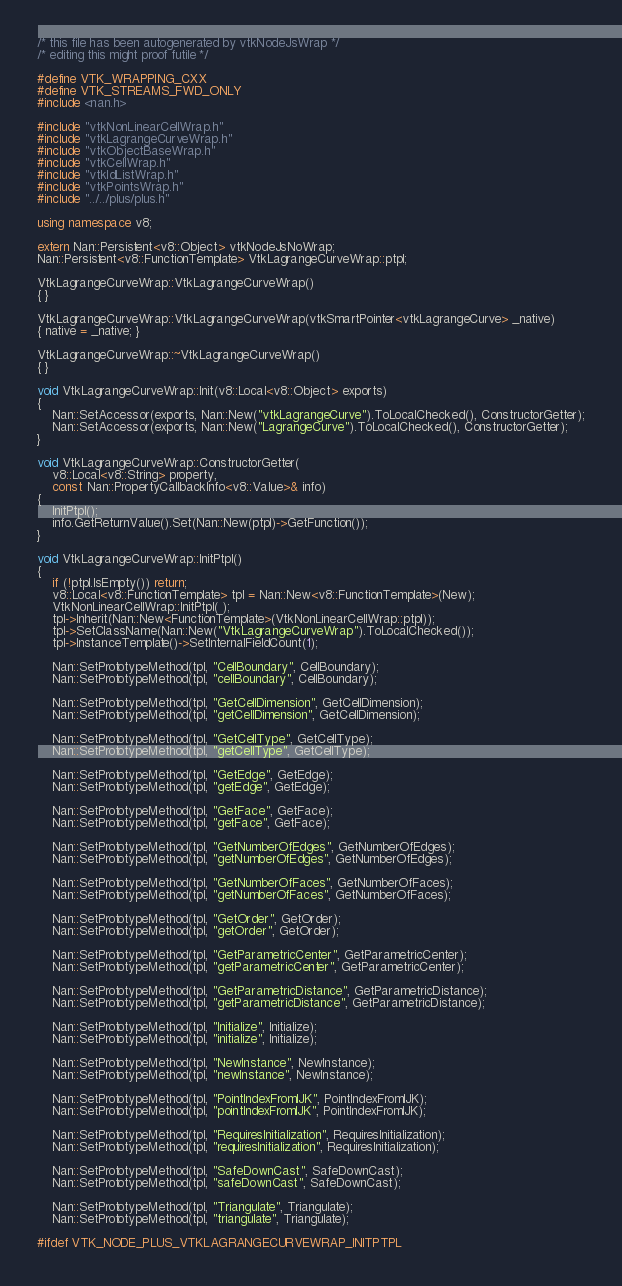Convert code to text. <code><loc_0><loc_0><loc_500><loc_500><_C++_>/* this file has been autogenerated by vtkNodeJsWrap */
/* editing this might proof futile */

#define VTK_WRAPPING_CXX
#define VTK_STREAMS_FWD_ONLY
#include <nan.h>

#include "vtkNonLinearCellWrap.h"
#include "vtkLagrangeCurveWrap.h"
#include "vtkObjectBaseWrap.h"
#include "vtkCellWrap.h"
#include "vtkIdListWrap.h"
#include "vtkPointsWrap.h"
#include "../../plus/plus.h"

using namespace v8;

extern Nan::Persistent<v8::Object> vtkNodeJsNoWrap;
Nan::Persistent<v8::FunctionTemplate> VtkLagrangeCurveWrap::ptpl;

VtkLagrangeCurveWrap::VtkLagrangeCurveWrap()
{ }

VtkLagrangeCurveWrap::VtkLagrangeCurveWrap(vtkSmartPointer<vtkLagrangeCurve> _native)
{ native = _native; }

VtkLagrangeCurveWrap::~VtkLagrangeCurveWrap()
{ }

void VtkLagrangeCurveWrap::Init(v8::Local<v8::Object> exports)
{
	Nan::SetAccessor(exports, Nan::New("vtkLagrangeCurve").ToLocalChecked(), ConstructorGetter);
	Nan::SetAccessor(exports, Nan::New("LagrangeCurve").ToLocalChecked(), ConstructorGetter);
}

void VtkLagrangeCurveWrap::ConstructorGetter(
	v8::Local<v8::String> property,
	const Nan::PropertyCallbackInfo<v8::Value>& info)
{
	InitPtpl();
	info.GetReturnValue().Set(Nan::New(ptpl)->GetFunction());
}

void VtkLagrangeCurveWrap::InitPtpl()
{
	if (!ptpl.IsEmpty()) return;
	v8::Local<v8::FunctionTemplate> tpl = Nan::New<v8::FunctionTemplate>(New);
	VtkNonLinearCellWrap::InitPtpl( );
	tpl->Inherit(Nan::New<FunctionTemplate>(VtkNonLinearCellWrap::ptpl));
	tpl->SetClassName(Nan::New("VtkLagrangeCurveWrap").ToLocalChecked());
	tpl->InstanceTemplate()->SetInternalFieldCount(1);

	Nan::SetPrototypeMethod(tpl, "CellBoundary", CellBoundary);
	Nan::SetPrototypeMethod(tpl, "cellBoundary", CellBoundary);

	Nan::SetPrototypeMethod(tpl, "GetCellDimension", GetCellDimension);
	Nan::SetPrototypeMethod(tpl, "getCellDimension", GetCellDimension);

	Nan::SetPrototypeMethod(tpl, "GetCellType", GetCellType);
	Nan::SetPrototypeMethod(tpl, "getCellType", GetCellType);

	Nan::SetPrototypeMethod(tpl, "GetEdge", GetEdge);
	Nan::SetPrototypeMethod(tpl, "getEdge", GetEdge);

	Nan::SetPrototypeMethod(tpl, "GetFace", GetFace);
	Nan::SetPrototypeMethod(tpl, "getFace", GetFace);

	Nan::SetPrototypeMethod(tpl, "GetNumberOfEdges", GetNumberOfEdges);
	Nan::SetPrototypeMethod(tpl, "getNumberOfEdges", GetNumberOfEdges);

	Nan::SetPrototypeMethod(tpl, "GetNumberOfFaces", GetNumberOfFaces);
	Nan::SetPrototypeMethod(tpl, "getNumberOfFaces", GetNumberOfFaces);

	Nan::SetPrototypeMethod(tpl, "GetOrder", GetOrder);
	Nan::SetPrototypeMethod(tpl, "getOrder", GetOrder);

	Nan::SetPrototypeMethod(tpl, "GetParametricCenter", GetParametricCenter);
	Nan::SetPrototypeMethod(tpl, "getParametricCenter", GetParametricCenter);

	Nan::SetPrototypeMethod(tpl, "GetParametricDistance", GetParametricDistance);
	Nan::SetPrototypeMethod(tpl, "getParametricDistance", GetParametricDistance);

	Nan::SetPrototypeMethod(tpl, "Initialize", Initialize);
	Nan::SetPrototypeMethod(tpl, "initialize", Initialize);

	Nan::SetPrototypeMethod(tpl, "NewInstance", NewInstance);
	Nan::SetPrototypeMethod(tpl, "newInstance", NewInstance);

	Nan::SetPrototypeMethod(tpl, "PointIndexFromIJK", PointIndexFromIJK);
	Nan::SetPrototypeMethod(tpl, "pointIndexFromIJK", PointIndexFromIJK);

	Nan::SetPrototypeMethod(tpl, "RequiresInitialization", RequiresInitialization);
	Nan::SetPrototypeMethod(tpl, "requiresInitialization", RequiresInitialization);

	Nan::SetPrototypeMethod(tpl, "SafeDownCast", SafeDownCast);
	Nan::SetPrototypeMethod(tpl, "safeDownCast", SafeDownCast);

	Nan::SetPrototypeMethod(tpl, "Triangulate", Triangulate);
	Nan::SetPrototypeMethod(tpl, "triangulate", Triangulate);

#ifdef VTK_NODE_PLUS_VTKLAGRANGECURVEWRAP_INITPTPL</code> 